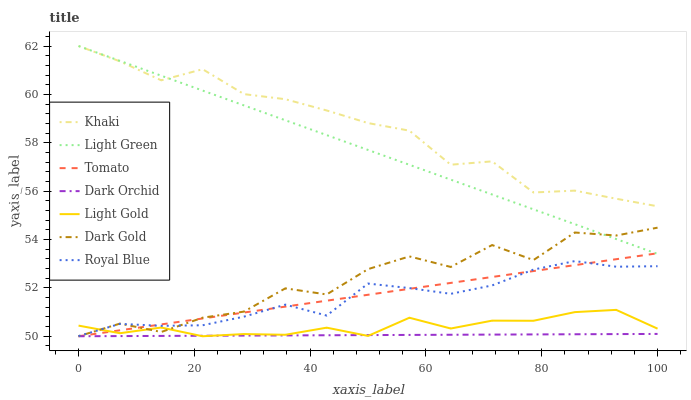Does Dark Orchid have the minimum area under the curve?
Answer yes or no. Yes. Does Khaki have the maximum area under the curve?
Answer yes or no. Yes. Does Dark Gold have the minimum area under the curve?
Answer yes or no. No. Does Dark Gold have the maximum area under the curve?
Answer yes or no. No. Is Light Green the smoothest?
Answer yes or no. Yes. Is Dark Gold the roughest?
Answer yes or no. Yes. Is Khaki the smoothest?
Answer yes or no. No. Is Khaki the roughest?
Answer yes or no. No. Does Tomato have the lowest value?
Answer yes or no. Yes. Does Khaki have the lowest value?
Answer yes or no. No. Does Light Green have the highest value?
Answer yes or no. Yes. Does Dark Gold have the highest value?
Answer yes or no. No. Is Royal Blue less than Khaki?
Answer yes or no. Yes. Is Royal Blue greater than Dark Orchid?
Answer yes or no. Yes. Does Royal Blue intersect Tomato?
Answer yes or no. Yes. Is Royal Blue less than Tomato?
Answer yes or no. No. Is Royal Blue greater than Tomato?
Answer yes or no. No. Does Royal Blue intersect Khaki?
Answer yes or no. No. 